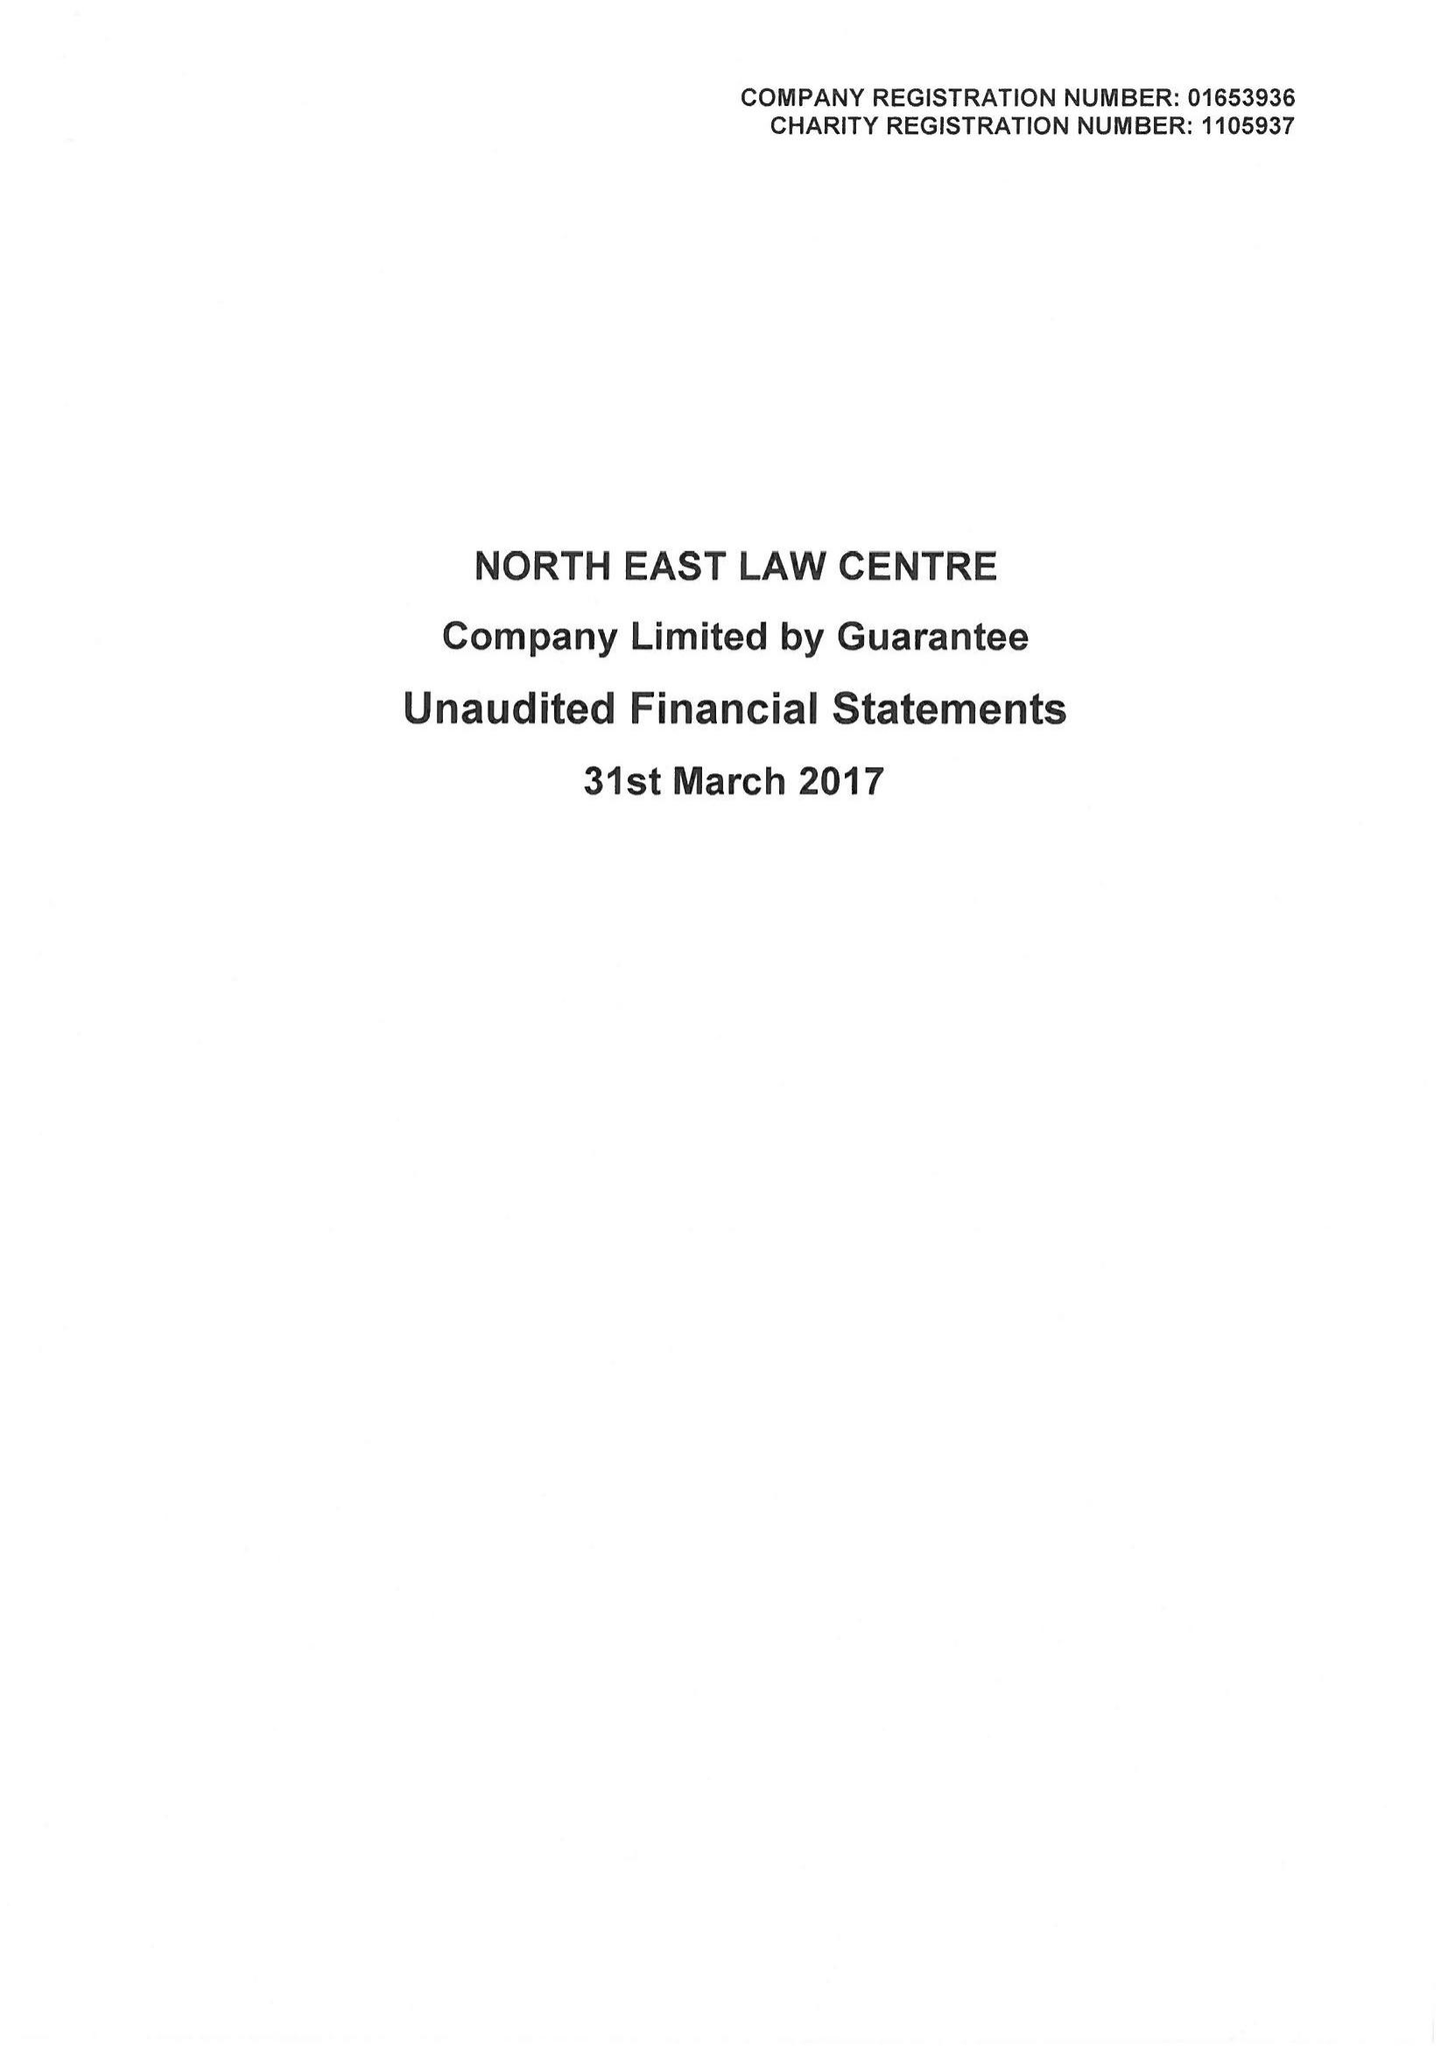What is the value for the income_annually_in_british_pounds?
Answer the question using a single word or phrase. 282840.00 